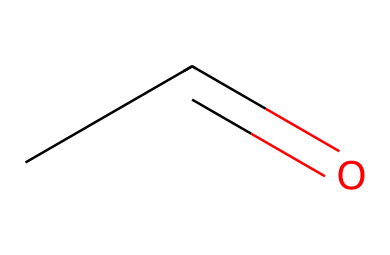What is the name of this chemical? The given SMILES representation "CC=O" corresponds to the chemical structure known as Acetaldehyde.
Answer: Acetaldehyde How many carbon atoms are present in this molecule? In the SMILES "CC=O", there are two carbon atoms indicated by the two 'C's present before the '=' sign.
Answer: 2 What type of functional group does Acetaldehyde contain? Acetaldehyde has a carbonyl group (C=O), which is characteristic of aldehydes, located at the end of the carbon chain.
Answer: aldehyde What is the molecular formula of Acetaldehyde? The SMILES "CC=O" indicates two carbon atoms, four hydrogen atoms, and one oxygen atom, which corresponds to the molecular formula C2H4O.
Answer: C2H4O What role does Acetaldehyde play in beer fermentation? In beer fermentation, Acetaldehyde acts as an intermediate compound produced during fermentation, contributing to flavor.
Answer: flavor Is Acetaldehyde soluble in water? Acetaldehyde is a polar molecule due to the presence of a carbonyl group, making it soluble in water.
Answer: yes What is the boiling point range of Acetaldehyde? The boiling point of Acetaldehyde is approximately 20.2 degrees Celsius, which indicates its volatile nature.
Answer: 20.2°C 